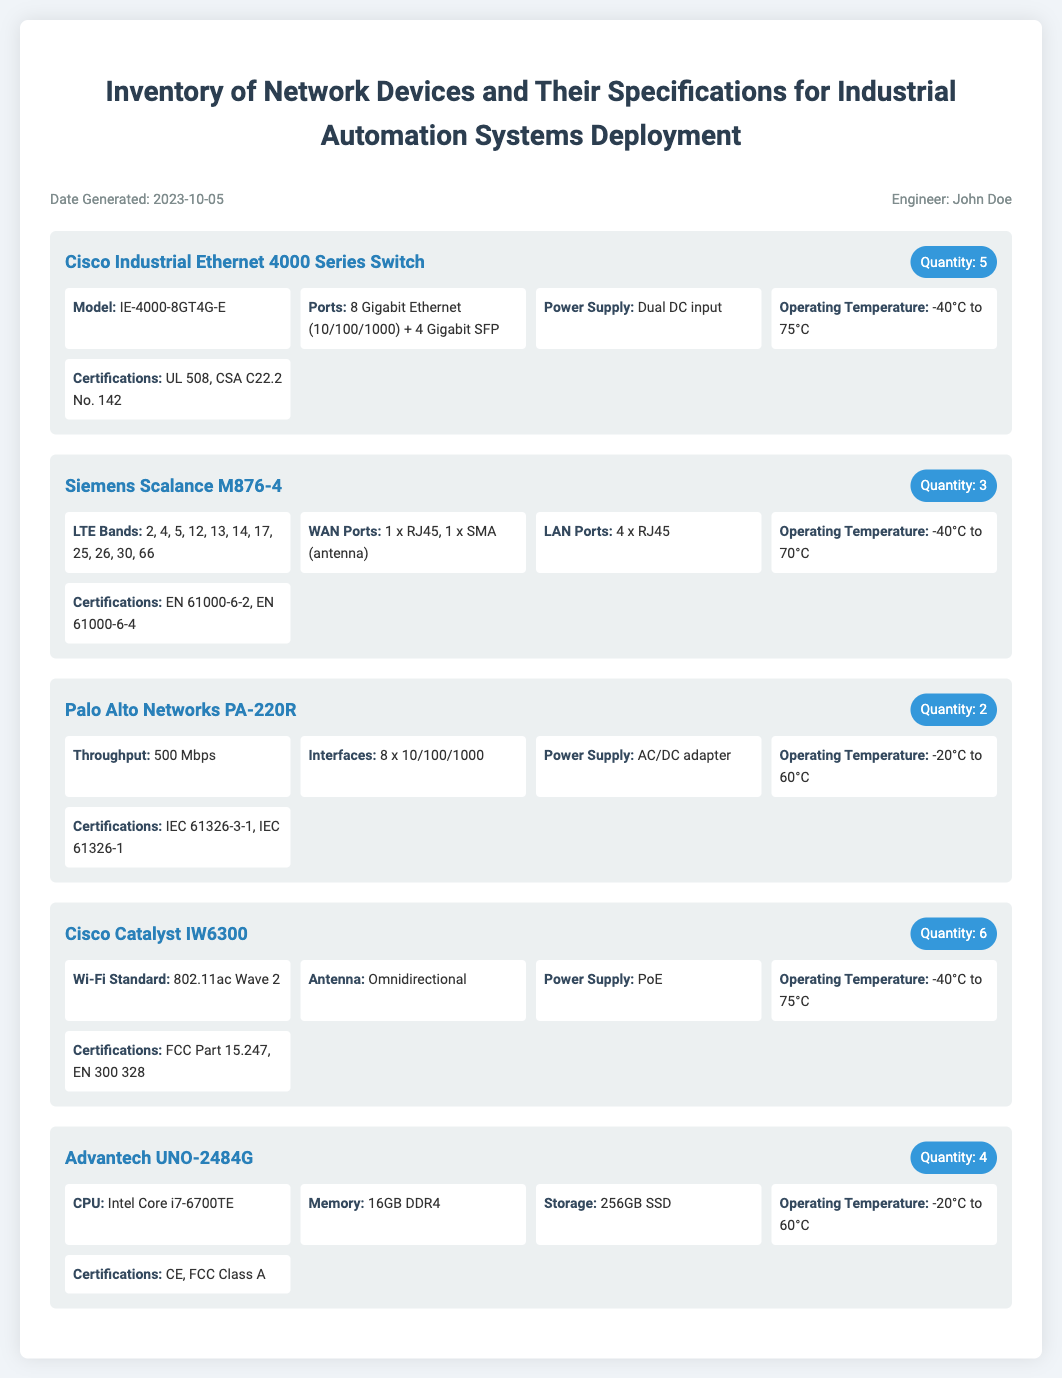What is the title of the document? The title is found at the top of the document.
Answer: Inventory of Network Devices and Their Specifications for Industrial Automation Systems Deployment How many Cisco Industrial Ethernet 4000 Series Switches are included? The quantity can be found next to the item name in the document.
Answer: 5 What is the model number of the Siemens Scalance M876-4? The model number is specified alongside the device’s name.
Answer: M876-4 What is the operating temperature range of the Cisco Catalyst IW6300? The operating temperature can be found in the specifications section of the device.
Answer: -40°C to 75°C How many LAN ports does the Siemens Scalance M876-4 have? The number of LAN ports is listed in the specifications section for the Siemens device.
Answer: 4 x RJ45 Which device has a throughput of 500 Mbps? The throughput specification is listed under the relevant device in the document.
Answer: Palo Alto Networks PA-220R What certification does the Advantech UNO-2484G have? Certifications for each device can be found in their specifications.
Answer: CE, FCC Class A Which network device is compatible with PoE? The use of Power over Ethernet is mentioned in the specifications section for that device.
Answer: Cisco Catalyst IW6300 What is the total quantity of Palo Alto Networks PA-220R devices? The total quantity can be found next to the device's name in the list.
Answer: 2 